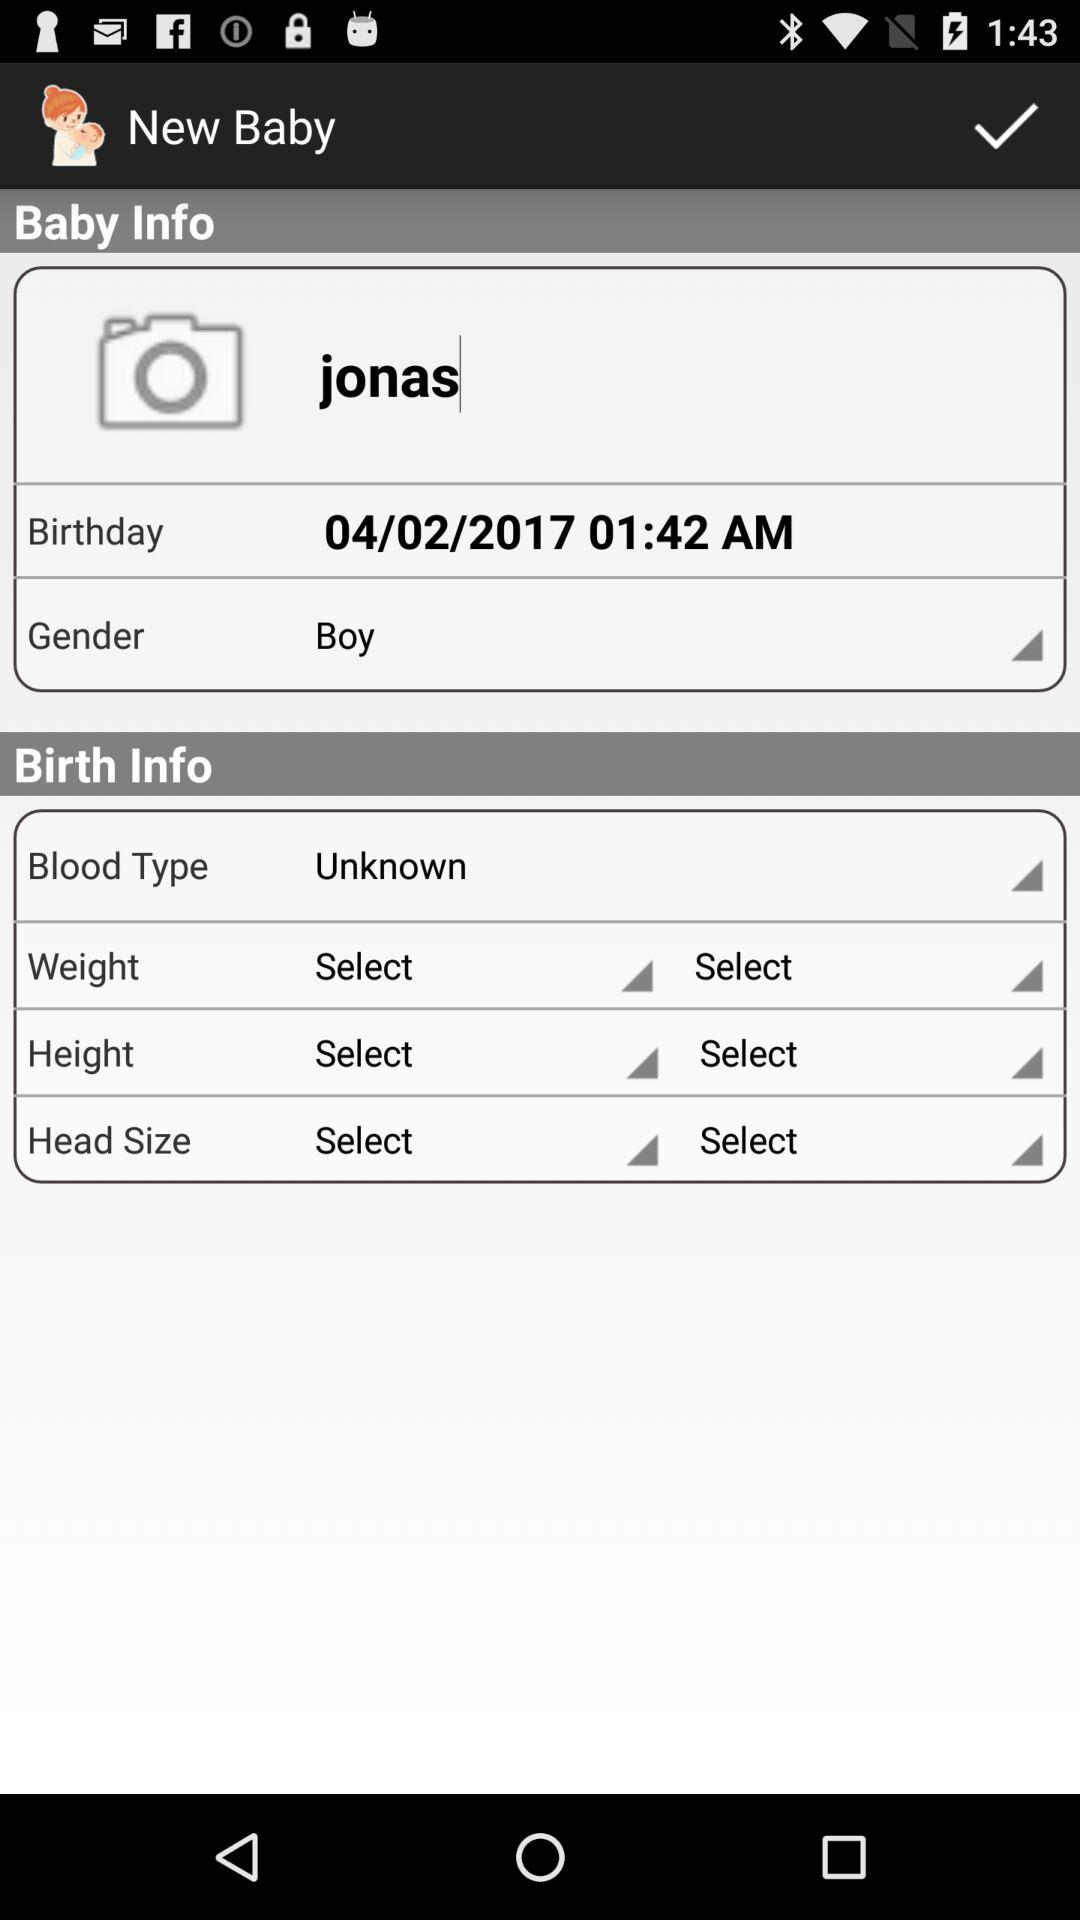What is the gender? The gender is boy. 